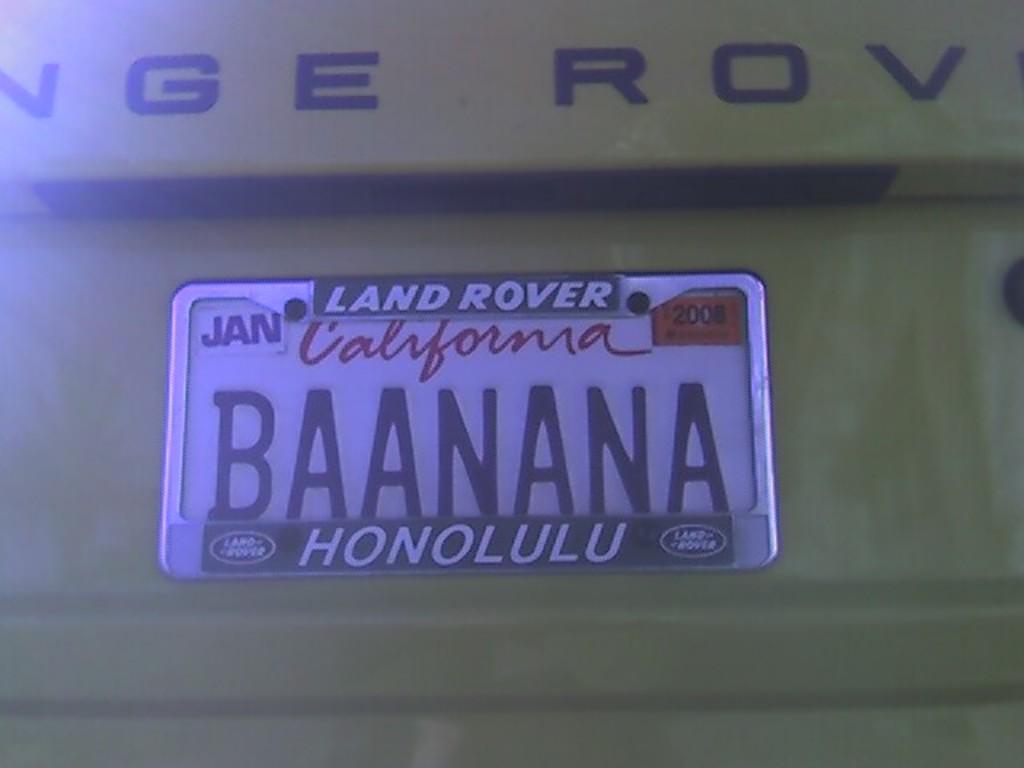What month is the tag from?
Give a very brief answer. January. Where is this tag from/?
Provide a succinct answer. California. 